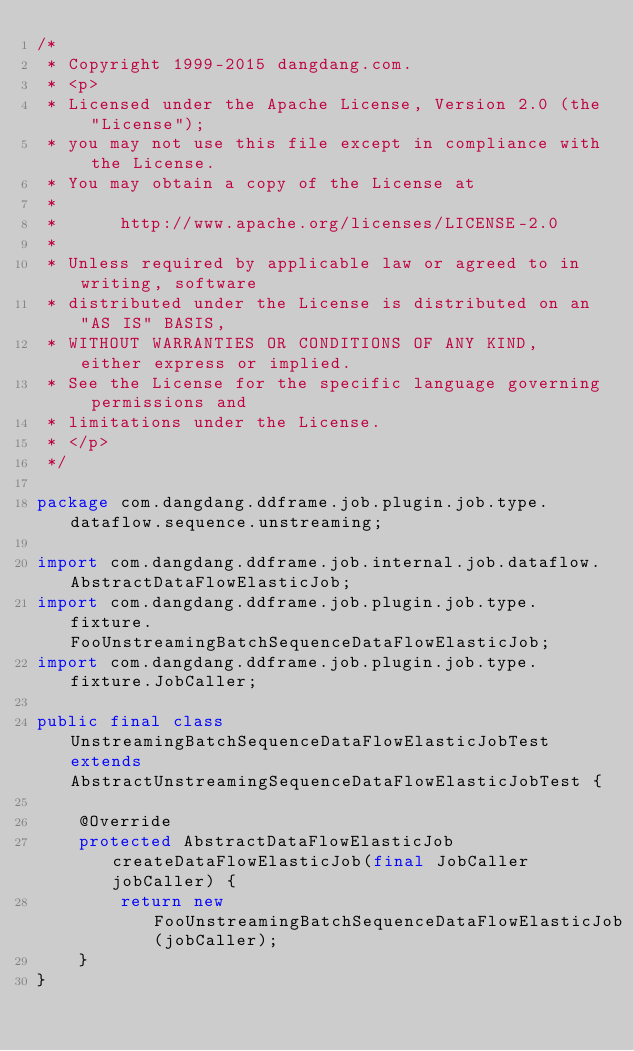Convert code to text. <code><loc_0><loc_0><loc_500><loc_500><_Java_>/*
 * Copyright 1999-2015 dangdang.com.
 * <p>
 * Licensed under the Apache License, Version 2.0 (the "License");
 * you may not use this file except in compliance with the License.
 * You may obtain a copy of the License at
 * 
 *      http://www.apache.org/licenses/LICENSE-2.0
 * 
 * Unless required by applicable law or agreed to in writing, software
 * distributed under the License is distributed on an "AS IS" BASIS,
 * WITHOUT WARRANTIES OR CONDITIONS OF ANY KIND, either express or implied.
 * See the License for the specific language governing permissions and
 * limitations under the License.
 * </p>
 */

package com.dangdang.ddframe.job.plugin.job.type.dataflow.sequence.unstreaming;

import com.dangdang.ddframe.job.internal.job.dataflow.AbstractDataFlowElasticJob;
import com.dangdang.ddframe.job.plugin.job.type.fixture.FooUnstreamingBatchSequenceDataFlowElasticJob;
import com.dangdang.ddframe.job.plugin.job.type.fixture.JobCaller;

public final class UnstreamingBatchSequenceDataFlowElasticJobTest extends AbstractUnstreamingSequenceDataFlowElasticJobTest {
    
    @Override
    protected AbstractDataFlowElasticJob createDataFlowElasticJob(final JobCaller jobCaller) {
        return new FooUnstreamingBatchSequenceDataFlowElasticJob(jobCaller);
    }
}
</code> 